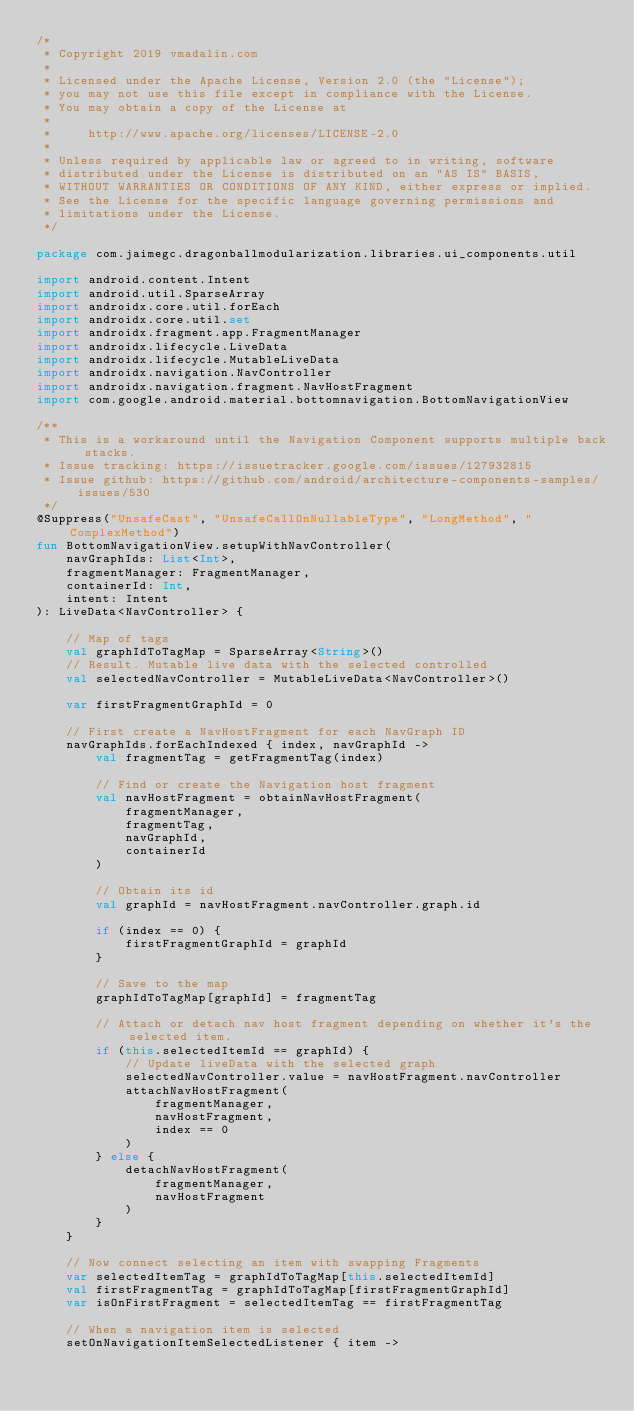Convert code to text. <code><loc_0><loc_0><loc_500><loc_500><_Kotlin_>/*
 * Copyright 2019 vmadalin.com
 *
 * Licensed under the Apache License, Version 2.0 (the "License");
 * you may not use this file except in compliance with the License.
 * You may obtain a copy of the License at
 *
 *     http://www.apache.org/licenses/LICENSE-2.0
 *
 * Unless required by applicable law or agreed to in writing, software
 * distributed under the License is distributed on an "AS IS" BASIS,
 * WITHOUT WARRANTIES OR CONDITIONS OF ANY KIND, either express or implied.
 * See the License for the specific language governing permissions and
 * limitations under the License.
 */

package com.jaimegc.dragonballmodularization.libraries.ui_components.util

import android.content.Intent
import android.util.SparseArray
import androidx.core.util.forEach
import androidx.core.util.set
import androidx.fragment.app.FragmentManager
import androidx.lifecycle.LiveData
import androidx.lifecycle.MutableLiveData
import androidx.navigation.NavController
import androidx.navigation.fragment.NavHostFragment
import com.google.android.material.bottomnavigation.BottomNavigationView

/**
 * This is a workaround until the Navigation Component supports multiple back stacks.
 * Issue tracking: https://issuetracker.google.com/issues/127932815
 * Issue github: https://github.com/android/architecture-components-samples/issues/530
 */
@Suppress("UnsafeCast", "UnsafeCallOnNullableType", "LongMethod", "ComplexMethod")
fun BottomNavigationView.setupWithNavController(
    navGraphIds: List<Int>,
    fragmentManager: FragmentManager,
    containerId: Int,
    intent: Intent
): LiveData<NavController> {

    // Map of tags
    val graphIdToTagMap = SparseArray<String>()
    // Result. Mutable live data with the selected controlled
    val selectedNavController = MutableLiveData<NavController>()

    var firstFragmentGraphId = 0

    // First create a NavHostFragment for each NavGraph ID
    navGraphIds.forEachIndexed { index, navGraphId ->
        val fragmentTag = getFragmentTag(index)

        // Find or create the Navigation host fragment
        val navHostFragment = obtainNavHostFragment(
            fragmentManager,
            fragmentTag,
            navGraphId,
            containerId
        )

        // Obtain its id
        val graphId = navHostFragment.navController.graph.id

        if (index == 0) {
            firstFragmentGraphId = graphId
        }

        // Save to the map
        graphIdToTagMap[graphId] = fragmentTag

        // Attach or detach nav host fragment depending on whether it's the selected item.
        if (this.selectedItemId == graphId) {
            // Update liveData with the selected graph
            selectedNavController.value = navHostFragment.navController
            attachNavHostFragment(
                fragmentManager,
                navHostFragment,
                index == 0
            )
        } else {
            detachNavHostFragment(
                fragmentManager,
                navHostFragment
            )
        }
    }

    // Now connect selecting an item with swapping Fragments
    var selectedItemTag = graphIdToTagMap[this.selectedItemId]
    val firstFragmentTag = graphIdToTagMap[firstFragmentGraphId]
    var isOnFirstFragment = selectedItemTag == firstFragmentTag

    // When a navigation item is selected
    setOnNavigationItemSelectedListener { item -></code> 